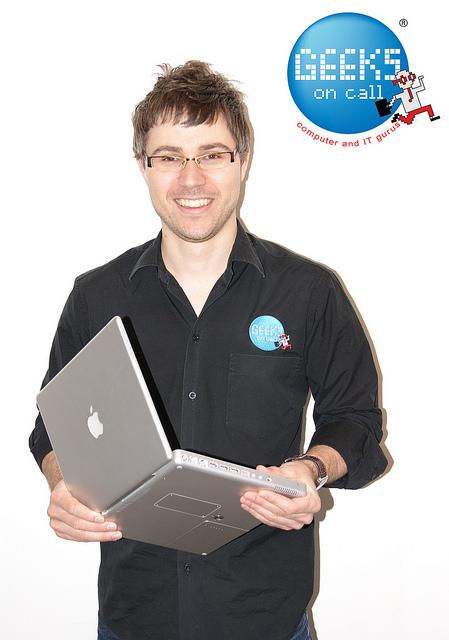Does that man have a prominent Adam's apple?
Give a very brief answer. Yes. What kind of computer is this man holding?
Concise answer only. Apple. What does the logo suggest this man is?
Answer briefly. Geek. 